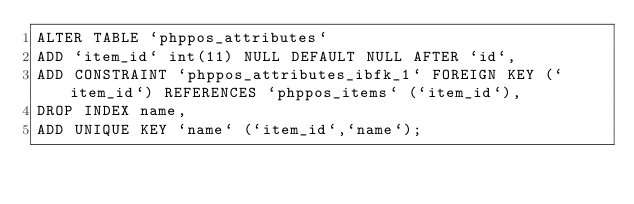Convert code to text. <code><loc_0><loc_0><loc_500><loc_500><_SQL_>ALTER TABLE `phppos_attributes`
ADD `item_id` int(11) NULL DEFAULT NULL AFTER `id`,
ADD CONSTRAINT `phppos_attributes_ibfk_1` FOREIGN KEY (`item_id`) REFERENCES `phppos_items` (`item_id`),
DROP INDEX name, 
ADD UNIQUE KEY `name` (`item_id`,`name`);

</code> 